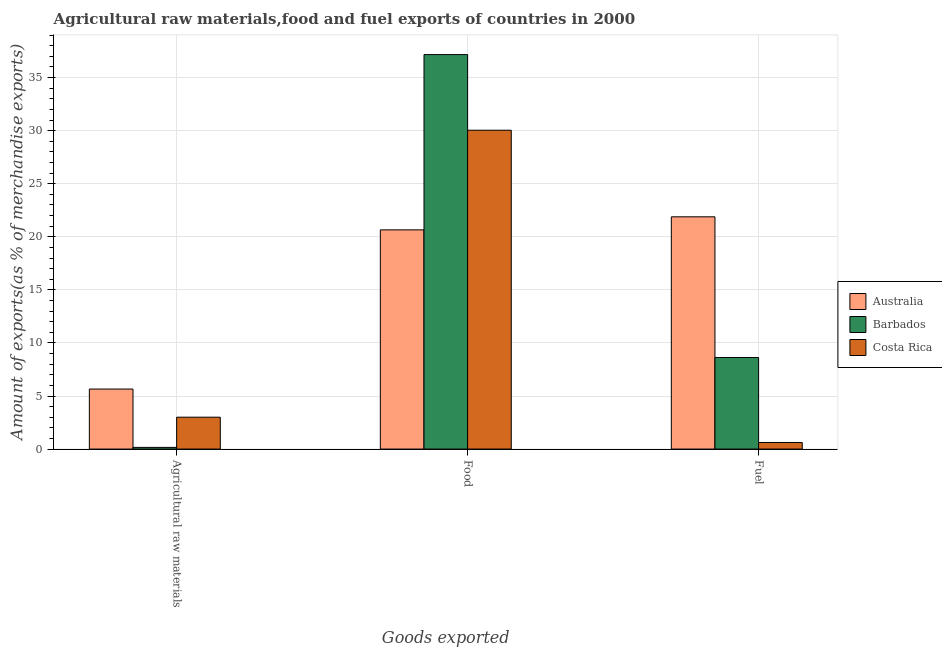How many different coloured bars are there?
Your answer should be compact. 3. Are the number of bars on each tick of the X-axis equal?
Provide a short and direct response. Yes. How many bars are there on the 1st tick from the left?
Give a very brief answer. 3. How many bars are there on the 1st tick from the right?
Offer a terse response. 3. What is the label of the 3rd group of bars from the left?
Offer a very short reply. Fuel. What is the percentage of raw materials exports in Barbados?
Your response must be concise. 0.16. Across all countries, what is the maximum percentage of food exports?
Your response must be concise. 37.16. Across all countries, what is the minimum percentage of food exports?
Your answer should be compact. 20.65. In which country was the percentage of food exports minimum?
Give a very brief answer. Australia. What is the total percentage of fuel exports in the graph?
Offer a very short reply. 31.12. What is the difference between the percentage of food exports in Costa Rica and that in Barbados?
Provide a short and direct response. -7.12. What is the difference between the percentage of food exports in Australia and the percentage of raw materials exports in Costa Rica?
Your answer should be compact. 17.65. What is the average percentage of fuel exports per country?
Offer a terse response. 10.37. What is the difference between the percentage of raw materials exports and percentage of food exports in Australia?
Offer a very short reply. -15. In how many countries, is the percentage of raw materials exports greater than 2 %?
Keep it short and to the point. 2. What is the ratio of the percentage of raw materials exports in Barbados to that in Costa Rica?
Provide a succinct answer. 0.05. What is the difference between the highest and the second highest percentage of fuel exports?
Offer a terse response. 13.26. What is the difference between the highest and the lowest percentage of raw materials exports?
Make the answer very short. 5.5. What does the 2nd bar from the right in Fuel represents?
Keep it short and to the point. Barbados. Is it the case that in every country, the sum of the percentage of raw materials exports and percentage of food exports is greater than the percentage of fuel exports?
Keep it short and to the point. Yes. Are all the bars in the graph horizontal?
Ensure brevity in your answer.  No. How many countries are there in the graph?
Make the answer very short. 3. Are the values on the major ticks of Y-axis written in scientific E-notation?
Your response must be concise. No. Where does the legend appear in the graph?
Provide a short and direct response. Center right. How many legend labels are there?
Give a very brief answer. 3. What is the title of the graph?
Ensure brevity in your answer.  Agricultural raw materials,food and fuel exports of countries in 2000. Does "Greece" appear as one of the legend labels in the graph?
Your answer should be compact. No. What is the label or title of the X-axis?
Your response must be concise. Goods exported. What is the label or title of the Y-axis?
Your answer should be very brief. Amount of exports(as % of merchandise exports). What is the Amount of exports(as % of merchandise exports) of Australia in Agricultural raw materials?
Ensure brevity in your answer.  5.65. What is the Amount of exports(as % of merchandise exports) of Barbados in Agricultural raw materials?
Make the answer very short. 0.16. What is the Amount of exports(as % of merchandise exports) in Costa Rica in Agricultural raw materials?
Provide a short and direct response. 3. What is the Amount of exports(as % of merchandise exports) in Australia in Food?
Your response must be concise. 20.65. What is the Amount of exports(as % of merchandise exports) in Barbados in Food?
Your answer should be compact. 37.16. What is the Amount of exports(as % of merchandise exports) of Costa Rica in Food?
Your response must be concise. 30.04. What is the Amount of exports(as % of merchandise exports) in Australia in Fuel?
Provide a short and direct response. 21.88. What is the Amount of exports(as % of merchandise exports) of Barbados in Fuel?
Give a very brief answer. 8.62. What is the Amount of exports(as % of merchandise exports) of Costa Rica in Fuel?
Provide a succinct answer. 0.62. Across all Goods exported, what is the maximum Amount of exports(as % of merchandise exports) in Australia?
Keep it short and to the point. 21.88. Across all Goods exported, what is the maximum Amount of exports(as % of merchandise exports) of Barbados?
Provide a short and direct response. 37.16. Across all Goods exported, what is the maximum Amount of exports(as % of merchandise exports) in Costa Rica?
Keep it short and to the point. 30.04. Across all Goods exported, what is the minimum Amount of exports(as % of merchandise exports) of Australia?
Your answer should be very brief. 5.65. Across all Goods exported, what is the minimum Amount of exports(as % of merchandise exports) of Barbados?
Provide a short and direct response. 0.16. Across all Goods exported, what is the minimum Amount of exports(as % of merchandise exports) of Costa Rica?
Provide a succinct answer. 0.62. What is the total Amount of exports(as % of merchandise exports) of Australia in the graph?
Your answer should be very brief. 48.19. What is the total Amount of exports(as % of merchandise exports) in Barbados in the graph?
Keep it short and to the point. 45.95. What is the total Amount of exports(as % of merchandise exports) of Costa Rica in the graph?
Provide a short and direct response. 33.66. What is the difference between the Amount of exports(as % of merchandise exports) in Australia in Agricultural raw materials and that in Food?
Your answer should be compact. -15. What is the difference between the Amount of exports(as % of merchandise exports) of Barbados in Agricultural raw materials and that in Food?
Your answer should be compact. -37.01. What is the difference between the Amount of exports(as % of merchandise exports) in Costa Rica in Agricultural raw materials and that in Food?
Your response must be concise. -27.03. What is the difference between the Amount of exports(as % of merchandise exports) in Australia in Agricultural raw materials and that in Fuel?
Ensure brevity in your answer.  -16.23. What is the difference between the Amount of exports(as % of merchandise exports) in Barbados in Agricultural raw materials and that in Fuel?
Ensure brevity in your answer.  -8.47. What is the difference between the Amount of exports(as % of merchandise exports) in Costa Rica in Agricultural raw materials and that in Fuel?
Your answer should be compact. 2.39. What is the difference between the Amount of exports(as % of merchandise exports) in Australia in Food and that in Fuel?
Keep it short and to the point. -1.23. What is the difference between the Amount of exports(as % of merchandise exports) of Barbados in Food and that in Fuel?
Your answer should be very brief. 28.54. What is the difference between the Amount of exports(as % of merchandise exports) in Costa Rica in Food and that in Fuel?
Ensure brevity in your answer.  29.42. What is the difference between the Amount of exports(as % of merchandise exports) in Australia in Agricultural raw materials and the Amount of exports(as % of merchandise exports) in Barbados in Food?
Give a very brief answer. -31.51. What is the difference between the Amount of exports(as % of merchandise exports) of Australia in Agricultural raw materials and the Amount of exports(as % of merchandise exports) of Costa Rica in Food?
Ensure brevity in your answer.  -24.38. What is the difference between the Amount of exports(as % of merchandise exports) in Barbados in Agricultural raw materials and the Amount of exports(as % of merchandise exports) in Costa Rica in Food?
Offer a terse response. -29.88. What is the difference between the Amount of exports(as % of merchandise exports) of Australia in Agricultural raw materials and the Amount of exports(as % of merchandise exports) of Barbados in Fuel?
Your answer should be very brief. -2.97. What is the difference between the Amount of exports(as % of merchandise exports) of Australia in Agricultural raw materials and the Amount of exports(as % of merchandise exports) of Costa Rica in Fuel?
Your response must be concise. 5.04. What is the difference between the Amount of exports(as % of merchandise exports) of Barbados in Agricultural raw materials and the Amount of exports(as % of merchandise exports) of Costa Rica in Fuel?
Keep it short and to the point. -0.46. What is the difference between the Amount of exports(as % of merchandise exports) of Australia in Food and the Amount of exports(as % of merchandise exports) of Barbados in Fuel?
Your answer should be compact. 12.03. What is the difference between the Amount of exports(as % of merchandise exports) of Australia in Food and the Amount of exports(as % of merchandise exports) of Costa Rica in Fuel?
Your answer should be very brief. 20.03. What is the difference between the Amount of exports(as % of merchandise exports) of Barbados in Food and the Amount of exports(as % of merchandise exports) of Costa Rica in Fuel?
Provide a short and direct response. 36.55. What is the average Amount of exports(as % of merchandise exports) in Australia per Goods exported?
Make the answer very short. 16.06. What is the average Amount of exports(as % of merchandise exports) of Barbados per Goods exported?
Your answer should be compact. 15.31. What is the average Amount of exports(as % of merchandise exports) of Costa Rica per Goods exported?
Give a very brief answer. 11.22. What is the difference between the Amount of exports(as % of merchandise exports) in Australia and Amount of exports(as % of merchandise exports) in Barbados in Agricultural raw materials?
Make the answer very short. 5.5. What is the difference between the Amount of exports(as % of merchandise exports) in Australia and Amount of exports(as % of merchandise exports) in Costa Rica in Agricultural raw materials?
Make the answer very short. 2.65. What is the difference between the Amount of exports(as % of merchandise exports) in Barbados and Amount of exports(as % of merchandise exports) in Costa Rica in Agricultural raw materials?
Offer a terse response. -2.85. What is the difference between the Amount of exports(as % of merchandise exports) of Australia and Amount of exports(as % of merchandise exports) of Barbados in Food?
Offer a terse response. -16.51. What is the difference between the Amount of exports(as % of merchandise exports) of Australia and Amount of exports(as % of merchandise exports) of Costa Rica in Food?
Make the answer very short. -9.39. What is the difference between the Amount of exports(as % of merchandise exports) of Barbados and Amount of exports(as % of merchandise exports) of Costa Rica in Food?
Your response must be concise. 7.12. What is the difference between the Amount of exports(as % of merchandise exports) of Australia and Amount of exports(as % of merchandise exports) of Barbados in Fuel?
Ensure brevity in your answer.  13.26. What is the difference between the Amount of exports(as % of merchandise exports) in Australia and Amount of exports(as % of merchandise exports) in Costa Rica in Fuel?
Your answer should be compact. 21.26. What is the difference between the Amount of exports(as % of merchandise exports) of Barbados and Amount of exports(as % of merchandise exports) of Costa Rica in Fuel?
Offer a terse response. 8.01. What is the ratio of the Amount of exports(as % of merchandise exports) of Australia in Agricultural raw materials to that in Food?
Ensure brevity in your answer.  0.27. What is the ratio of the Amount of exports(as % of merchandise exports) of Barbados in Agricultural raw materials to that in Food?
Offer a very short reply. 0. What is the ratio of the Amount of exports(as % of merchandise exports) of Australia in Agricultural raw materials to that in Fuel?
Provide a succinct answer. 0.26. What is the ratio of the Amount of exports(as % of merchandise exports) of Barbados in Agricultural raw materials to that in Fuel?
Offer a very short reply. 0.02. What is the ratio of the Amount of exports(as % of merchandise exports) in Costa Rica in Agricultural raw materials to that in Fuel?
Provide a succinct answer. 4.86. What is the ratio of the Amount of exports(as % of merchandise exports) in Australia in Food to that in Fuel?
Provide a succinct answer. 0.94. What is the ratio of the Amount of exports(as % of merchandise exports) in Barbados in Food to that in Fuel?
Provide a short and direct response. 4.31. What is the ratio of the Amount of exports(as % of merchandise exports) in Costa Rica in Food to that in Fuel?
Your response must be concise. 48.61. What is the difference between the highest and the second highest Amount of exports(as % of merchandise exports) of Australia?
Your response must be concise. 1.23. What is the difference between the highest and the second highest Amount of exports(as % of merchandise exports) in Barbados?
Provide a succinct answer. 28.54. What is the difference between the highest and the second highest Amount of exports(as % of merchandise exports) of Costa Rica?
Ensure brevity in your answer.  27.03. What is the difference between the highest and the lowest Amount of exports(as % of merchandise exports) in Australia?
Keep it short and to the point. 16.23. What is the difference between the highest and the lowest Amount of exports(as % of merchandise exports) in Barbados?
Provide a succinct answer. 37.01. What is the difference between the highest and the lowest Amount of exports(as % of merchandise exports) of Costa Rica?
Keep it short and to the point. 29.42. 